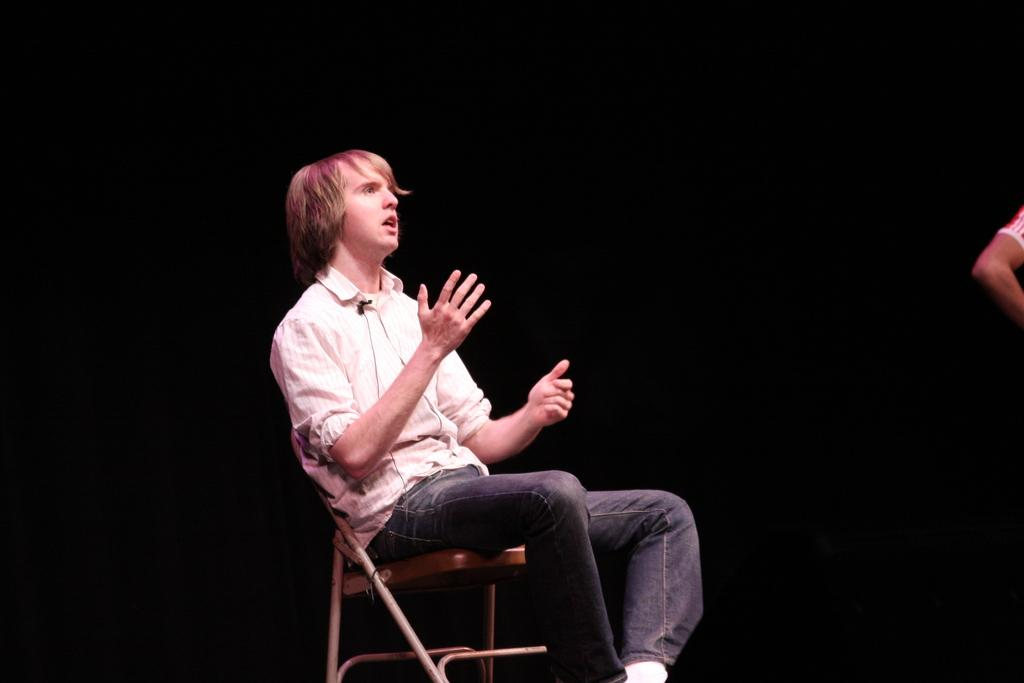Who is present in the image? There is a man in the image. What is the man doing in the image? The man is sitting on a chair. Can you describe any other person's body part visible in the image? There is a hand of a person present beside the man. What type of giants can be seen in the image? There are no giants present in the image. What kind of vessel is being used by the man in the image? The image does not show any vessel being used by the man. 